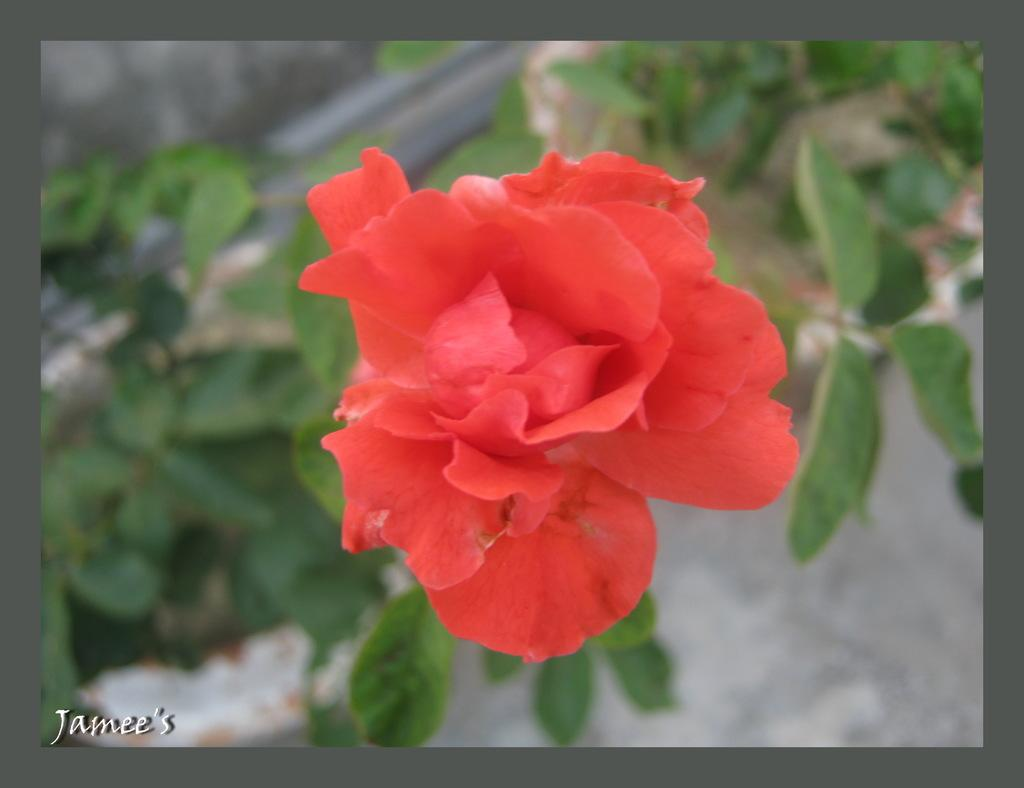What is present in the image? There is a plant with a red flower and leaves in the image. Are there any other plants visible in the image? Yes, there are plants in the background of the image. Where are the plants located? The plants are on the land. Is there any text in the image? Yes, there is some text in the bottom left corner of the image. What type of scarf is being used to protect the plant from destruction in the image? There is no scarf or destruction present in the image; it features a plant with a red flower and leaves, along with other plants in the background. 